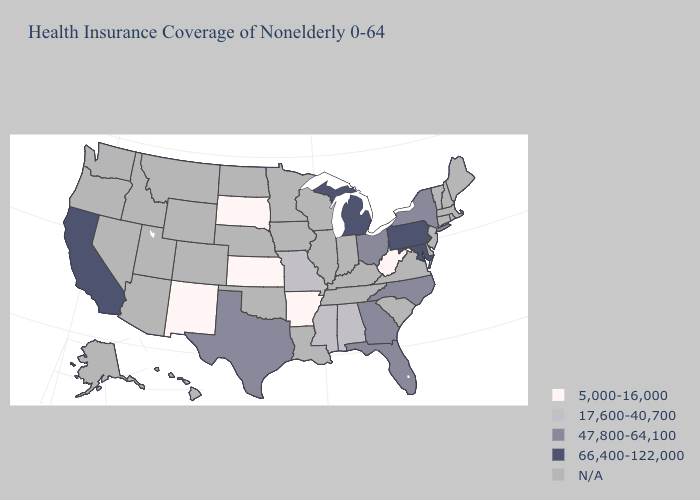What is the lowest value in states that border South Carolina?
Answer briefly. 47,800-64,100. What is the value of Wisconsin?
Be succinct. N/A. What is the highest value in the USA?
Keep it brief. 66,400-122,000. Name the states that have a value in the range 47,800-64,100?
Give a very brief answer. Florida, Georgia, New York, North Carolina, Ohio, Texas. What is the value of New York?
Write a very short answer. 47,800-64,100. What is the highest value in the USA?
Keep it brief. 66,400-122,000. Is the legend a continuous bar?
Write a very short answer. No. Does New Mexico have the lowest value in the USA?
Concise answer only. Yes. Which states have the lowest value in the USA?
Short answer required. Arkansas, Kansas, New Mexico, South Dakota, West Virginia. What is the value of California?
Short answer required. 66,400-122,000. Which states have the highest value in the USA?
Short answer required. California, Maryland, Michigan, Pennsylvania. 